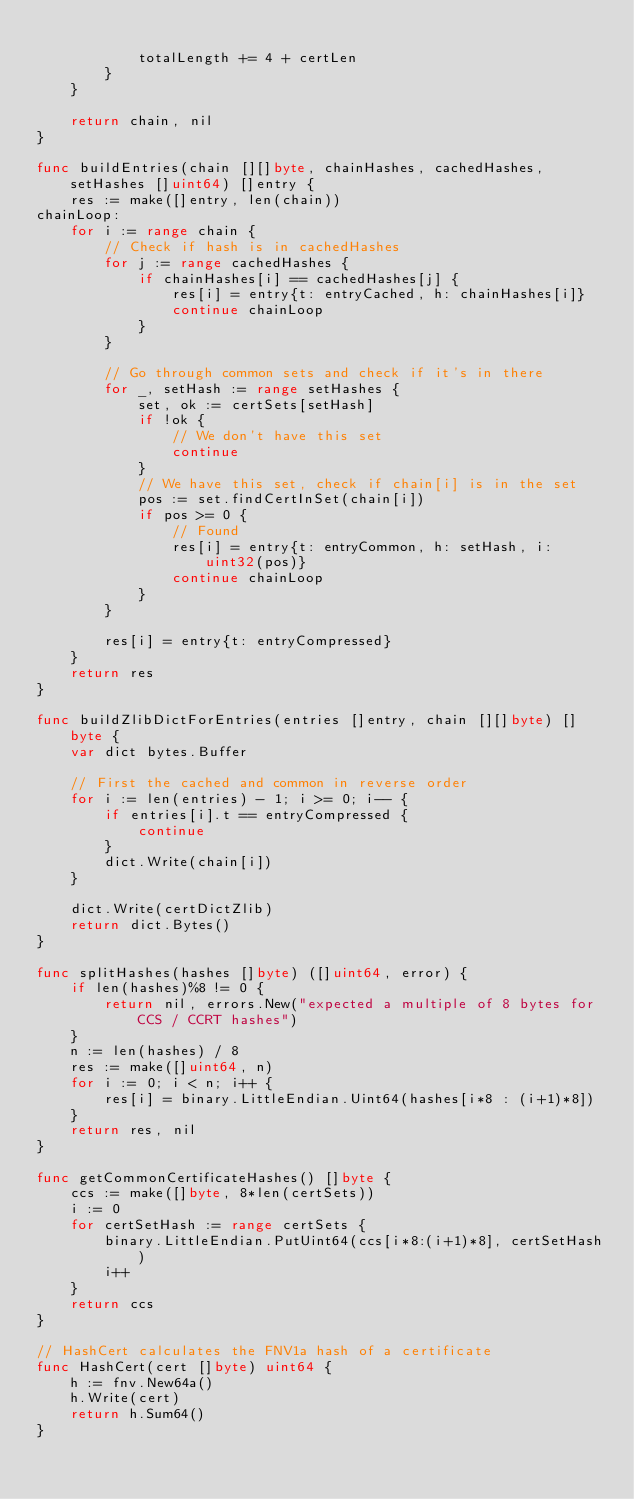Convert code to text. <code><loc_0><loc_0><loc_500><loc_500><_Go_>
			totalLength += 4 + certLen
		}
	}

	return chain, nil
}

func buildEntries(chain [][]byte, chainHashes, cachedHashes, setHashes []uint64) []entry {
	res := make([]entry, len(chain))
chainLoop:
	for i := range chain {
		// Check if hash is in cachedHashes
		for j := range cachedHashes {
			if chainHashes[i] == cachedHashes[j] {
				res[i] = entry{t: entryCached, h: chainHashes[i]}
				continue chainLoop
			}
		}

		// Go through common sets and check if it's in there
		for _, setHash := range setHashes {
			set, ok := certSets[setHash]
			if !ok {
				// We don't have this set
				continue
			}
			// We have this set, check if chain[i] is in the set
			pos := set.findCertInSet(chain[i])
			if pos >= 0 {
				// Found
				res[i] = entry{t: entryCommon, h: setHash, i: uint32(pos)}
				continue chainLoop
			}
		}

		res[i] = entry{t: entryCompressed}
	}
	return res
}

func buildZlibDictForEntries(entries []entry, chain [][]byte) []byte {
	var dict bytes.Buffer

	// First the cached and common in reverse order
	for i := len(entries) - 1; i >= 0; i-- {
		if entries[i].t == entryCompressed {
			continue
		}
		dict.Write(chain[i])
	}

	dict.Write(certDictZlib)
	return dict.Bytes()
}

func splitHashes(hashes []byte) ([]uint64, error) {
	if len(hashes)%8 != 0 {
		return nil, errors.New("expected a multiple of 8 bytes for CCS / CCRT hashes")
	}
	n := len(hashes) / 8
	res := make([]uint64, n)
	for i := 0; i < n; i++ {
		res[i] = binary.LittleEndian.Uint64(hashes[i*8 : (i+1)*8])
	}
	return res, nil
}

func getCommonCertificateHashes() []byte {
	ccs := make([]byte, 8*len(certSets))
	i := 0
	for certSetHash := range certSets {
		binary.LittleEndian.PutUint64(ccs[i*8:(i+1)*8], certSetHash)
		i++
	}
	return ccs
}

// HashCert calculates the FNV1a hash of a certificate
func HashCert(cert []byte) uint64 {
	h := fnv.New64a()
	h.Write(cert)
	return h.Sum64()
}
</code> 